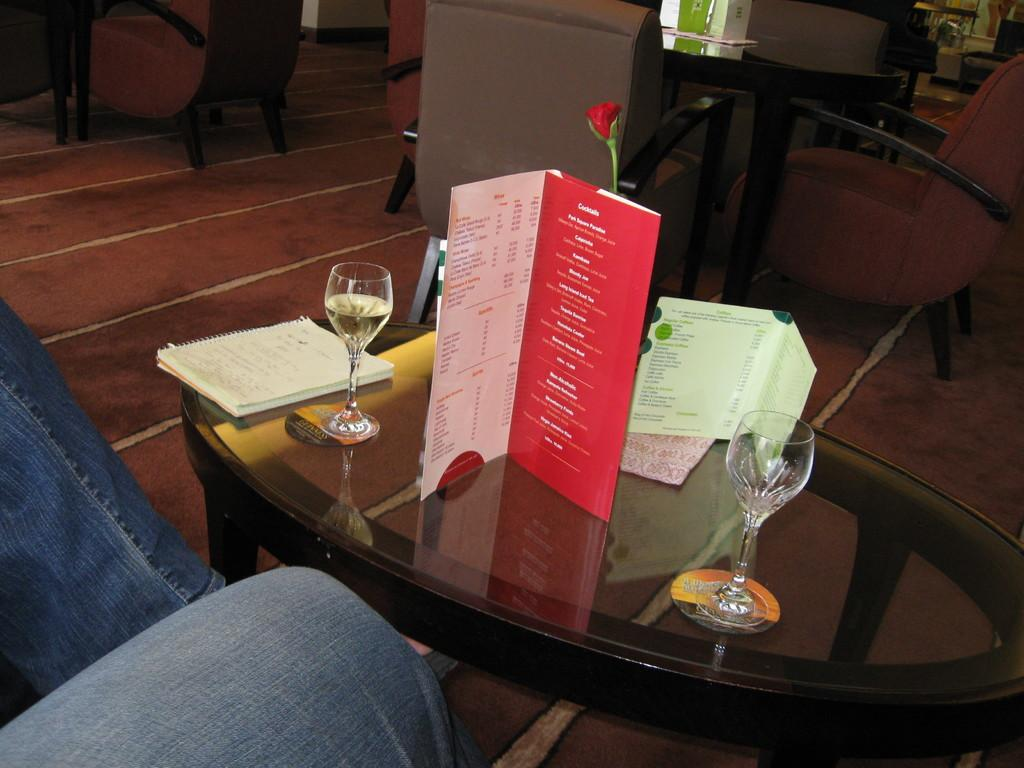What is present on the table in the image? There is a wine glass on the table in the image. What is the wine glass holding? The wine glass is empty in the image. Is there anything attached to the wine glass? Yes, there is a paper card on the wine glass. What type of orange is being used as a coaster for the wine glass in the image? There is no orange present in the image; it is a paper card on the wine glass. 